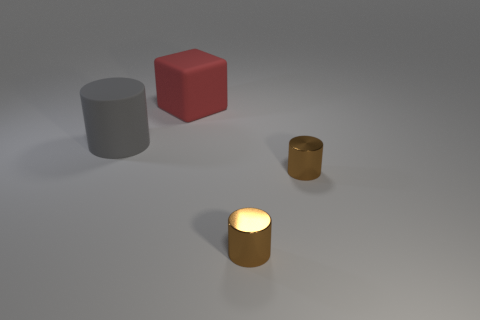How many objects are objects in front of the big gray cylinder or red rubber things?
Keep it short and to the point. 3. The big cylinder that is made of the same material as the big block is what color?
Make the answer very short. Gray. Is there a cylinder that has the same size as the gray rubber thing?
Offer a terse response. No. How many things are either gray cylinders in front of the big red thing or big objects left of the large cube?
Ensure brevity in your answer.  1. The rubber thing that is the same size as the gray rubber cylinder is what shape?
Your answer should be very brief. Cube. Are there any other matte objects that have the same shape as the big gray rubber thing?
Provide a succinct answer. No. Is the number of brown metallic objects less than the number of big gray objects?
Give a very brief answer. No. There is a matte object that is to the left of the cube; is it the same size as the object that is behind the gray cylinder?
Provide a succinct answer. Yes. What number of things are big purple matte blocks or matte things?
Provide a succinct answer. 2. There is a large rubber object in front of the large thing that is behind the big gray object; how many brown cylinders are on the right side of it?
Your response must be concise. 2. 